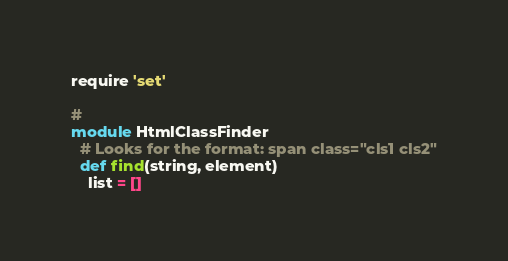Convert code to text. <code><loc_0><loc_0><loc_500><loc_500><_Ruby_>require 'set'

#
module HtmlClassFinder
  # Looks for the format: span class="cls1 cls2"
  def find(string, element)
    list = []</code> 